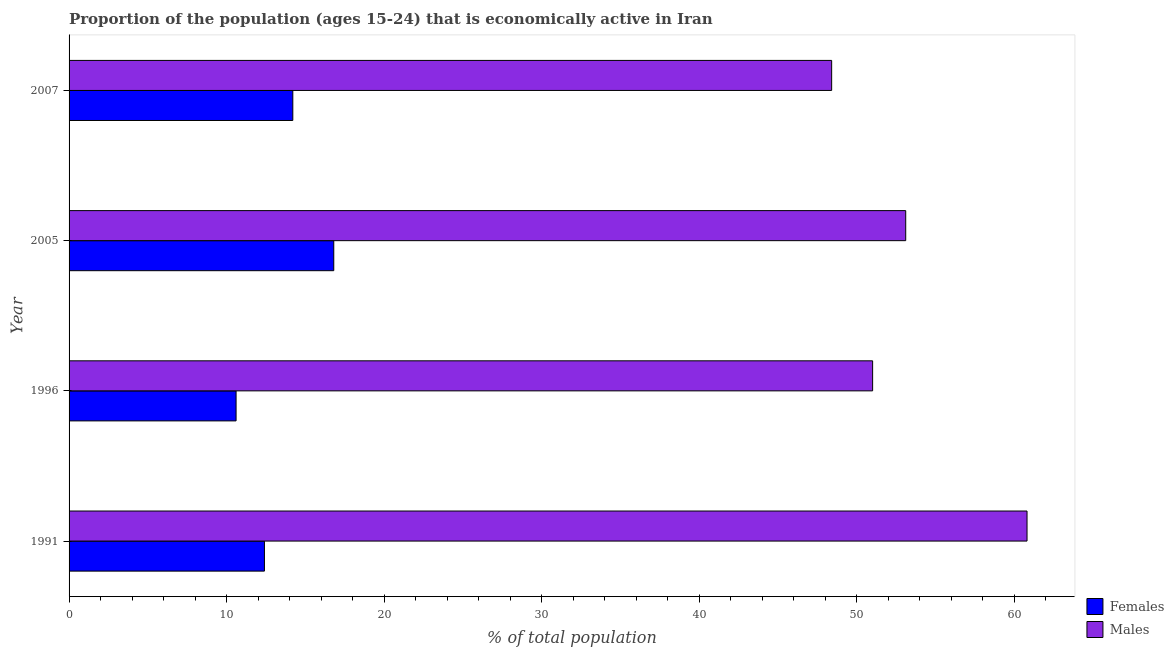Are the number of bars per tick equal to the number of legend labels?
Give a very brief answer. Yes. How many bars are there on the 4th tick from the top?
Keep it short and to the point. 2. How many bars are there on the 3rd tick from the bottom?
Provide a succinct answer. 2. What is the percentage of economically active male population in 2005?
Keep it short and to the point. 53.1. Across all years, what is the maximum percentage of economically active female population?
Keep it short and to the point. 16.8. Across all years, what is the minimum percentage of economically active female population?
Offer a very short reply. 10.6. What is the total percentage of economically active male population in the graph?
Offer a terse response. 213.3. What is the difference between the percentage of economically active female population in 1996 and that in 2005?
Your answer should be very brief. -6.2. What is the difference between the percentage of economically active male population in 1996 and the percentage of economically active female population in 2007?
Keep it short and to the point. 36.8. What is the average percentage of economically active male population per year?
Provide a short and direct response. 53.33. In the year 2007, what is the difference between the percentage of economically active female population and percentage of economically active male population?
Provide a succinct answer. -34.2. In how many years, is the percentage of economically active female population greater than 28 %?
Ensure brevity in your answer.  0. What is the ratio of the percentage of economically active male population in 1996 to that in 2007?
Give a very brief answer. 1.05. Is the percentage of economically active female population in 2005 less than that in 2007?
Offer a terse response. No. What is the difference between the highest and the second highest percentage of economically active male population?
Make the answer very short. 7.7. Is the sum of the percentage of economically active female population in 2005 and 2007 greater than the maximum percentage of economically active male population across all years?
Provide a short and direct response. No. What does the 2nd bar from the top in 1996 represents?
Provide a succinct answer. Females. What does the 2nd bar from the bottom in 2005 represents?
Offer a very short reply. Males. Does the graph contain any zero values?
Keep it short and to the point. No. Does the graph contain grids?
Your answer should be compact. No. Where does the legend appear in the graph?
Provide a short and direct response. Bottom right. How many legend labels are there?
Offer a terse response. 2. What is the title of the graph?
Make the answer very short. Proportion of the population (ages 15-24) that is economically active in Iran. Does "GDP" appear as one of the legend labels in the graph?
Offer a terse response. No. What is the label or title of the X-axis?
Give a very brief answer. % of total population. What is the % of total population in Females in 1991?
Provide a short and direct response. 12.4. What is the % of total population of Males in 1991?
Your answer should be very brief. 60.8. What is the % of total population in Females in 1996?
Ensure brevity in your answer.  10.6. What is the % of total population of Males in 1996?
Offer a very short reply. 51. What is the % of total population in Females in 2005?
Ensure brevity in your answer.  16.8. What is the % of total population of Males in 2005?
Make the answer very short. 53.1. What is the % of total population in Females in 2007?
Offer a terse response. 14.2. What is the % of total population of Males in 2007?
Offer a terse response. 48.4. Across all years, what is the maximum % of total population in Females?
Give a very brief answer. 16.8. Across all years, what is the maximum % of total population of Males?
Provide a short and direct response. 60.8. Across all years, what is the minimum % of total population in Females?
Give a very brief answer. 10.6. Across all years, what is the minimum % of total population in Males?
Offer a terse response. 48.4. What is the total % of total population of Males in the graph?
Provide a short and direct response. 213.3. What is the difference between the % of total population in Males in 1991 and that in 1996?
Your answer should be very brief. 9.8. What is the difference between the % of total population of Males in 1991 and that in 2007?
Ensure brevity in your answer.  12.4. What is the difference between the % of total population in Males in 1996 and that in 2005?
Give a very brief answer. -2.1. What is the difference between the % of total population of Females in 1996 and that in 2007?
Ensure brevity in your answer.  -3.6. What is the difference between the % of total population of Females in 1991 and the % of total population of Males in 1996?
Your answer should be very brief. -38.6. What is the difference between the % of total population in Females in 1991 and the % of total population in Males in 2005?
Your response must be concise. -40.7. What is the difference between the % of total population of Females in 1991 and the % of total population of Males in 2007?
Ensure brevity in your answer.  -36. What is the difference between the % of total population of Females in 1996 and the % of total population of Males in 2005?
Offer a terse response. -42.5. What is the difference between the % of total population of Females in 1996 and the % of total population of Males in 2007?
Ensure brevity in your answer.  -37.8. What is the difference between the % of total population in Females in 2005 and the % of total population in Males in 2007?
Provide a succinct answer. -31.6. What is the average % of total population in Females per year?
Keep it short and to the point. 13.5. What is the average % of total population in Males per year?
Ensure brevity in your answer.  53.33. In the year 1991, what is the difference between the % of total population in Females and % of total population in Males?
Your answer should be very brief. -48.4. In the year 1996, what is the difference between the % of total population in Females and % of total population in Males?
Your response must be concise. -40.4. In the year 2005, what is the difference between the % of total population of Females and % of total population of Males?
Make the answer very short. -36.3. In the year 2007, what is the difference between the % of total population in Females and % of total population in Males?
Your response must be concise. -34.2. What is the ratio of the % of total population of Females in 1991 to that in 1996?
Your response must be concise. 1.17. What is the ratio of the % of total population in Males in 1991 to that in 1996?
Your response must be concise. 1.19. What is the ratio of the % of total population of Females in 1991 to that in 2005?
Give a very brief answer. 0.74. What is the ratio of the % of total population in Males in 1991 to that in 2005?
Provide a succinct answer. 1.15. What is the ratio of the % of total population in Females in 1991 to that in 2007?
Your response must be concise. 0.87. What is the ratio of the % of total population of Males in 1991 to that in 2007?
Provide a succinct answer. 1.26. What is the ratio of the % of total population of Females in 1996 to that in 2005?
Your response must be concise. 0.63. What is the ratio of the % of total population in Males in 1996 to that in 2005?
Give a very brief answer. 0.96. What is the ratio of the % of total population in Females in 1996 to that in 2007?
Your response must be concise. 0.75. What is the ratio of the % of total population of Males in 1996 to that in 2007?
Give a very brief answer. 1.05. What is the ratio of the % of total population of Females in 2005 to that in 2007?
Your answer should be very brief. 1.18. What is the ratio of the % of total population of Males in 2005 to that in 2007?
Ensure brevity in your answer.  1.1. What is the difference between the highest and the second highest % of total population in Females?
Keep it short and to the point. 2.6. What is the difference between the highest and the lowest % of total population in Males?
Keep it short and to the point. 12.4. 